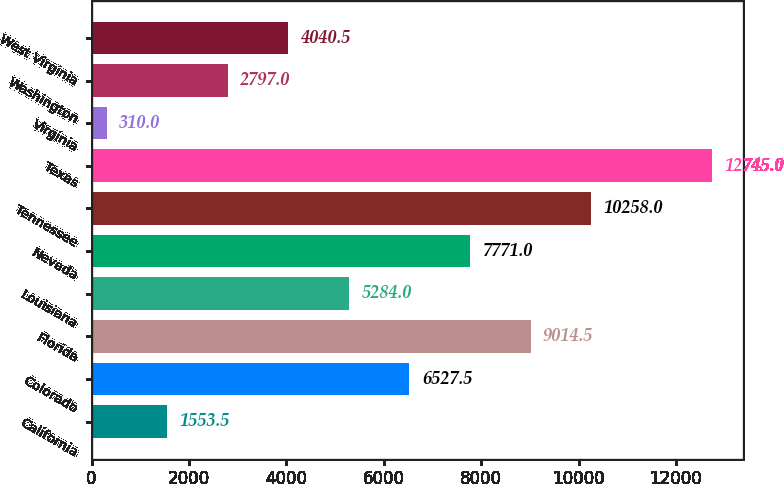Convert chart. <chart><loc_0><loc_0><loc_500><loc_500><bar_chart><fcel>California<fcel>Colorado<fcel>Florida<fcel>Louisiana<fcel>Nevada<fcel>Tennessee<fcel>Texas<fcel>Virginia<fcel>Washington<fcel>West Virginia<nl><fcel>1553.5<fcel>6527.5<fcel>9014.5<fcel>5284<fcel>7771<fcel>10258<fcel>12745<fcel>310<fcel>2797<fcel>4040.5<nl></chart> 